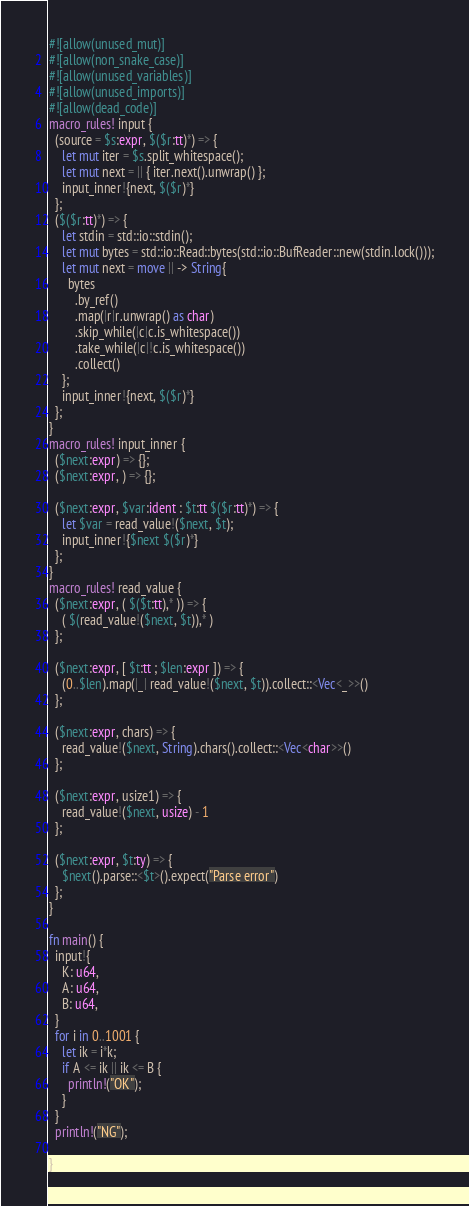Convert code to text. <code><loc_0><loc_0><loc_500><loc_500><_Rust_>#![allow(unused_mut)]
#![allow(non_snake_case)]
#![allow(unused_variables)]
#![allow(unused_imports)]
#![allow(dead_code)]
macro_rules! input {
  (source = $s:expr, $($r:tt)*) => {
    let mut iter = $s.split_whitespace();
    let mut next = || { iter.next().unwrap() };
    input_inner!{next, $($r)*}
  };
  ($($r:tt)*) => {
    let stdin = std::io::stdin();
    let mut bytes = std::io::Read::bytes(std::io::BufReader::new(stdin.lock()));
    let mut next = move || -> String{
      bytes
        .by_ref()
        .map(|r|r.unwrap() as char)
        .skip_while(|c|c.is_whitespace())
        .take_while(|c|!c.is_whitespace())
        .collect()
    };
    input_inner!{next, $($r)*}
  };
}
macro_rules! input_inner {
  ($next:expr) => {};
  ($next:expr, ) => {};

  ($next:expr, $var:ident : $t:tt $($r:tt)*) => {
    let $var = read_value!($next, $t);
    input_inner!{$next $($r)*}
  };
}
macro_rules! read_value {
  ($next:expr, ( $($t:tt),* )) => {
    ( $(read_value!($next, $t)),* )
  };

  ($next:expr, [ $t:tt ; $len:expr ]) => {
    (0..$len).map(|_| read_value!($next, $t)).collect::<Vec<_>>()
  };

  ($next:expr, chars) => {
    read_value!($next, String).chars().collect::<Vec<char>>()
  };

  ($next:expr, usize1) => {
    read_value!($next, usize) - 1
  };

  ($next:expr, $t:ty) => {
    $next().parse::<$t>().expect("Parse error")
  };
}

fn main() {
  input!{
    K: u64,
    A: u64,
    B: u64,
  }
  for i in 0..1001 {
    let ik = i*k;
    if A <= ik || ik <= B {
      println!("OK");
    }
  }
  println!("NG");

}

</code> 